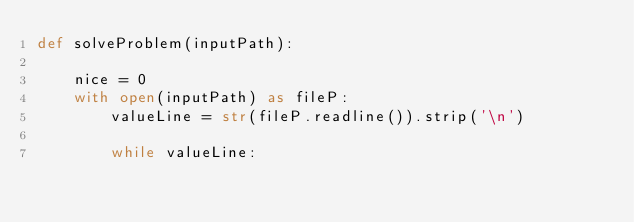Convert code to text. <code><loc_0><loc_0><loc_500><loc_500><_Python_>def solveProblem(inputPath):

    nice = 0
    with open(inputPath) as fileP:
        valueLine = str(fileP.readline()).strip('\n')
        
        while valueLine:</code> 